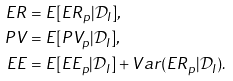Convert formula to latex. <formula><loc_0><loc_0><loc_500><loc_500>E R & = E [ E R _ { p } | \mathcal { D } _ { I } ] , \\ P V & = E [ P V _ { p } | \mathcal { D } _ { I } ] , \\ E E & = E [ E E _ { p } | \mathcal { D } _ { I } ] + V a r ( E R _ { p } | \mathcal { D } _ { I } ) .</formula> 